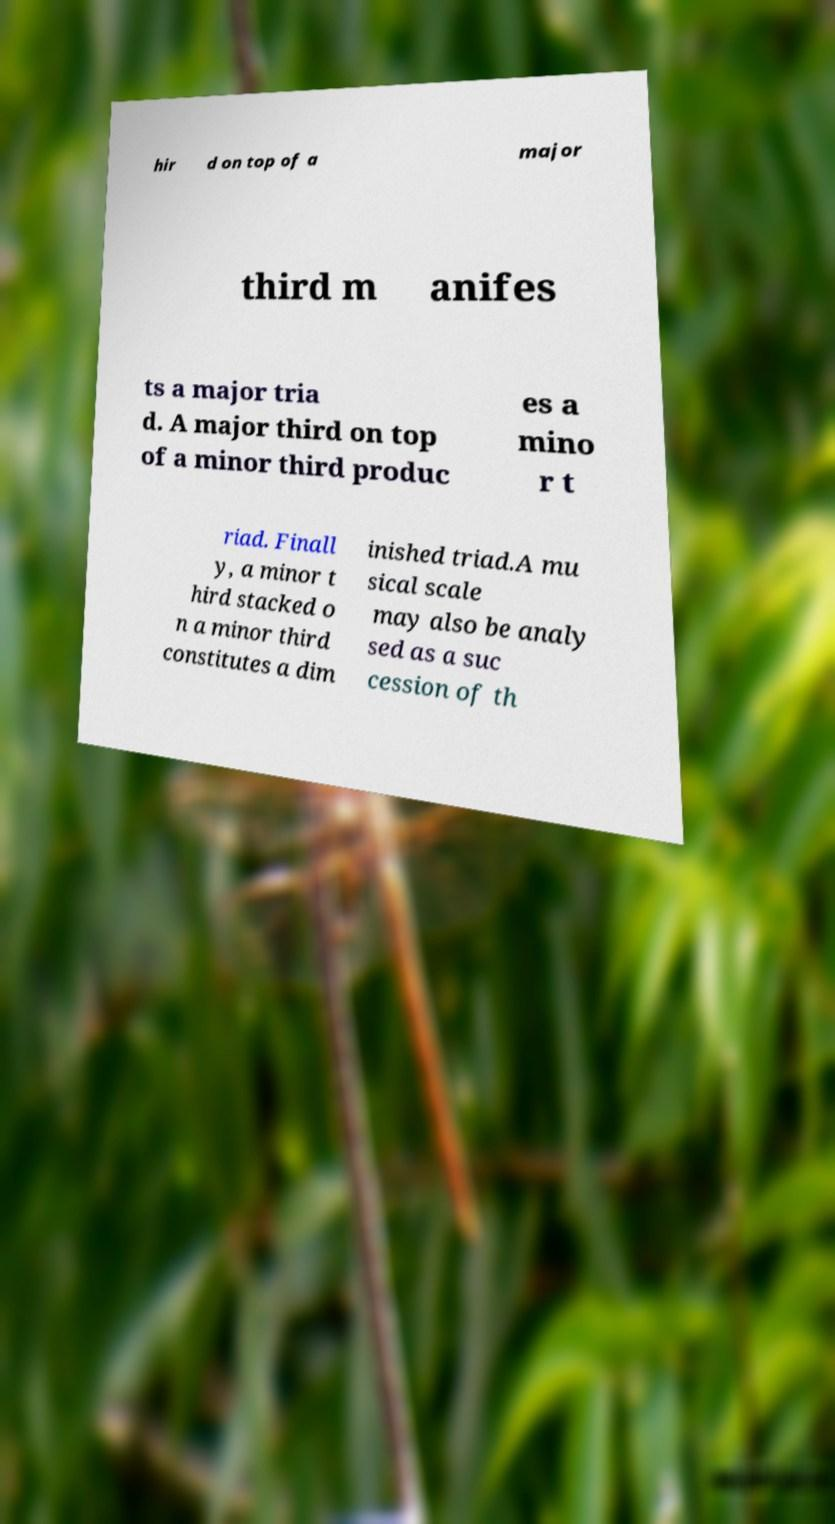Could you assist in decoding the text presented in this image and type it out clearly? hir d on top of a major third m anifes ts a major tria d. A major third on top of a minor third produc es a mino r t riad. Finall y, a minor t hird stacked o n a minor third constitutes a dim inished triad.A mu sical scale may also be analy sed as a suc cession of th 